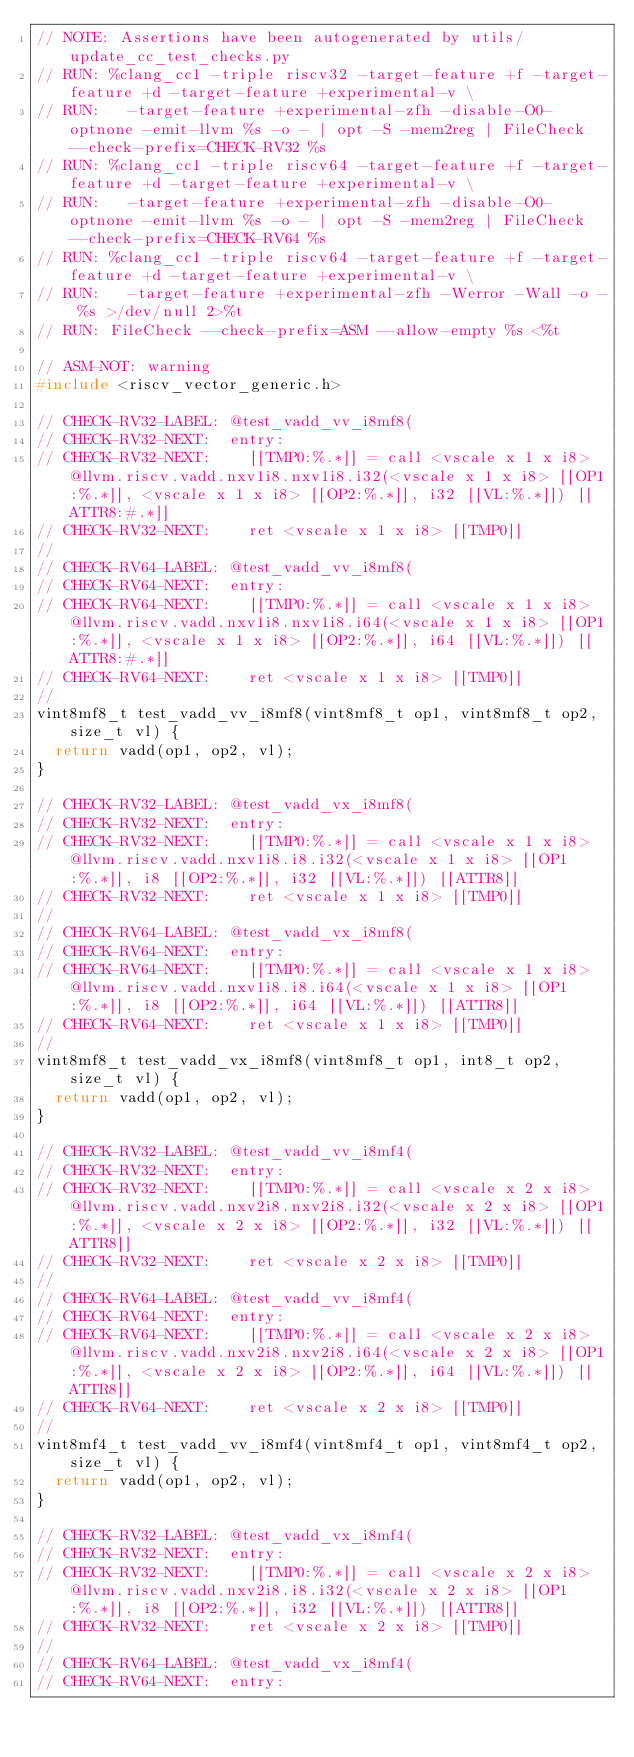<code> <loc_0><loc_0><loc_500><loc_500><_C_>// NOTE: Assertions have been autogenerated by utils/update_cc_test_checks.py
// RUN: %clang_cc1 -triple riscv32 -target-feature +f -target-feature +d -target-feature +experimental-v \
// RUN:   -target-feature +experimental-zfh -disable-O0-optnone -emit-llvm %s -o - | opt -S -mem2reg | FileCheck --check-prefix=CHECK-RV32 %s
// RUN: %clang_cc1 -triple riscv64 -target-feature +f -target-feature +d -target-feature +experimental-v \
// RUN:   -target-feature +experimental-zfh -disable-O0-optnone -emit-llvm %s -o - | opt -S -mem2reg | FileCheck --check-prefix=CHECK-RV64 %s
// RUN: %clang_cc1 -triple riscv64 -target-feature +f -target-feature +d -target-feature +experimental-v \
// RUN:   -target-feature +experimental-zfh -Werror -Wall -o - %s >/dev/null 2>%t
// RUN: FileCheck --check-prefix=ASM --allow-empty %s <%t

// ASM-NOT: warning
#include <riscv_vector_generic.h>

// CHECK-RV32-LABEL: @test_vadd_vv_i8mf8(
// CHECK-RV32-NEXT:  entry:
// CHECK-RV32-NEXT:    [[TMP0:%.*]] = call <vscale x 1 x i8> @llvm.riscv.vadd.nxv1i8.nxv1i8.i32(<vscale x 1 x i8> [[OP1:%.*]], <vscale x 1 x i8> [[OP2:%.*]], i32 [[VL:%.*]]) [[ATTR8:#.*]]
// CHECK-RV32-NEXT:    ret <vscale x 1 x i8> [[TMP0]]
//
// CHECK-RV64-LABEL: @test_vadd_vv_i8mf8(
// CHECK-RV64-NEXT:  entry:
// CHECK-RV64-NEXT:    [[TMP0:%.*]] = call <vscale x 1 x i8> @llvm.riscv.vadd.nxv1i8.nxv1i8.i64(<vscale x 1 x i8> [[OP1:%.*]], <vscale x 1 x i8> [[OP2:%.*]], i64 [[VL:%.*]]) [[ATTR8:#.*]]
// CHECK-RV64-NEXT:    ret <vscale x 1 x i8> [[TMP0]]
//
vint8mf8_t test_vadd_vv_i8mf8(vint8mf8_t op1, vint8mf8_t op2, size_t vl) {
  return vadd(op1, op2, vl);
}

// CHECK-RV32-LABEL: @test_vadd_vx_i8mf8(
// CHECK-RV32-NEXT:  entry:
// CHECK-RV32-NEXT:    [[TMP0:%.*]] = call <vscale x 1 x i8> @llvm.riscv.vadd.nxv1i8.i8.i32(<vscale x 1 x i8> [[OP1:%.*]], i8 [[OP2:%.*]], i32 [[VL:%.*]]) [[ATTR8]]
// CHECK-RV32-NEXT:    ret <vscale x 1 x i8> [[TMP0]]
//
// CHECK-RV64-LABEL: @test_vadd_vx_i8mf8(
// CHECK-RV64-NEXT:  entry:
// CHECK-RV64-NEXT:    [[TMP0:%.*]] = call <vscale x 1 x i8> @llvm.riscv.vadd.nxv1i8.i8.i64(<vscale x 1 x i8> [[OP1:%.*]], i8 [[OP2:%.*]], i64 [[VL:%.*]]) [[ATTR8]]
// CHECK-RV64-NEXT:    ret <vscale x 1 x i8> [[TMP0]]
//
vint8mf8_t test_vadd_vx_i8mf8(vint8mf8_t op1, int8_t op2, size_t vl) {
  return vadd(op1, op2, vl);
}

// CHECK-RV32-LABEL: @test_vadd_vv_i8mf4(
// CHECK-RV32-NEXT:  entry:
// CHECK-RV32-NEXT:    [[TMP0:%.*]] = call <vscale x 2 x i8> @llvm.riscv.vadd.nxv2i8.nxv2i8.i32(<vscale x 2 x i8> [[OP1:%.*]], <vscale x 2 x i8> [[OP2:%.*]], i32 [[VL:%.*]]) [[ATTR8]]
// CHECK-RV32-NEXT:    ret <vscale x 2 x i8> [[TMP0]]
//
// CHECK-RV64-LABEL: @test_vadd_vv_i8mf4(
// CHECK-RV64-NEXT:  entry:
// CHECK-RV64-NEXT:    [[TMP0:%.*]] = call <vscale x 2 x i8> @llvm.riscv.vadd.nxv2i8.nxv2i8.i64(<vscale x 2 x i8> [[OP1:%.*]], <vscale x 2 x i8> [[OP2:%.*]], i64 [[VL:%.*]]) [[ATTR8]]
// CHECK-RV64-NEXT:    ret <vscale x 2 x i8> [[TMP0]]
//
vint8mf4_t test_vadd_vv_i8mf4(vint8mf4_t op1, vint8mf4_t op2, size_t vl) {
  return vadd(op1, op2, vl);
}

// CHECK-RV32-LABEL: @test_vadd_vx_i8mf4(
// CHECK-RV32-NEXT:  entry:
// CHECK-RV32-NEXT:    [[TMP0:%.*]] = call <vscale x 2 x i8> @llvm.riscv.vadd.nxv2i8.i8.i32(<vscale x 2 x i8> [[OP1:%.*]], i8 [[OP2:%.*]], i32 [[VL:%.*]]) [[ATTR8]]
// CHECK-RV32-NEXT:    ret <vscale x 2 x i8> [[TMP0]]
//
// CHECK-RV64-LABEL: @test_vadd_vx_i8mf4(
// CHECK-RV64-NEXT:  entry:</code> 